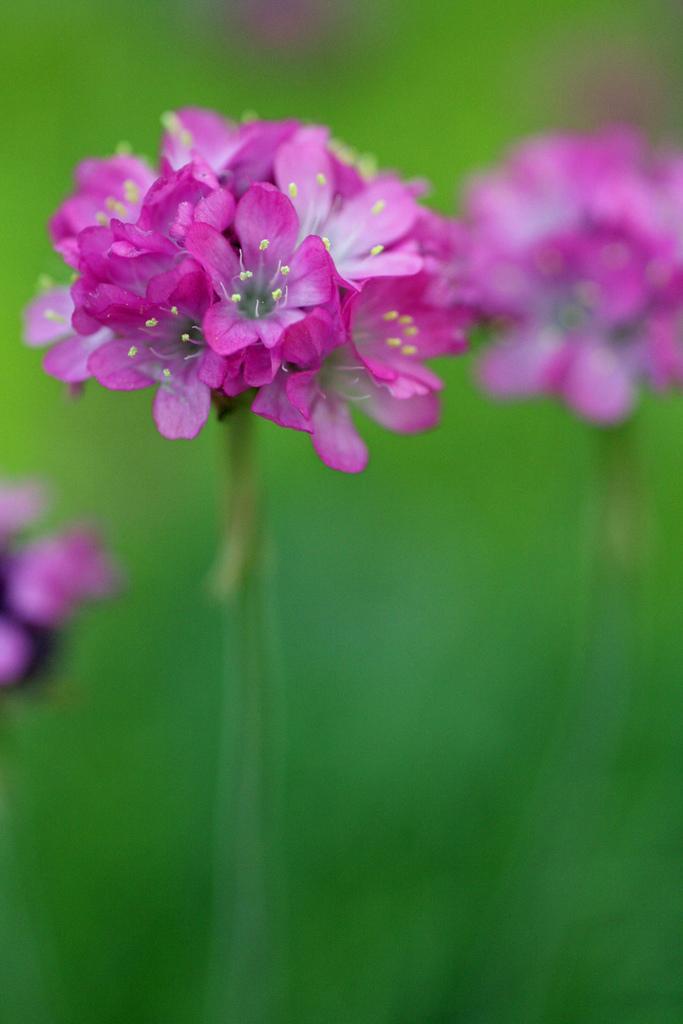Can you describe this image briefly? In this image in the foreground there are pink color flowers, and there is blurry background. 